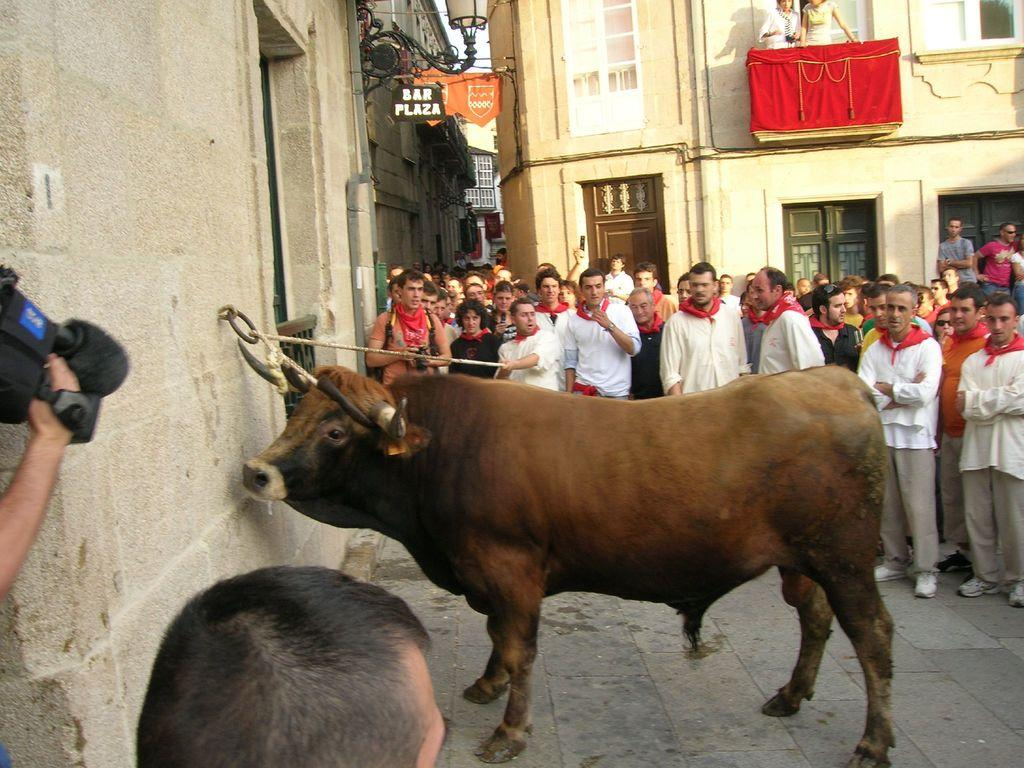What animal is the main subject of the image? There is a bull in the image. How is the bull restrained in the image? The bull is tied to a wall. Who is holding the rope connected to the bull? A person is holding a rope caught around the bull. What can be seen in the background of the image? There are buildings visible behind the crowd. What type of quartz can be seen in the image? There is no quartz present in the image. What level of danger is the person holding the rope in? The image does not provide information about the level of danger the person holding the rope is in. 